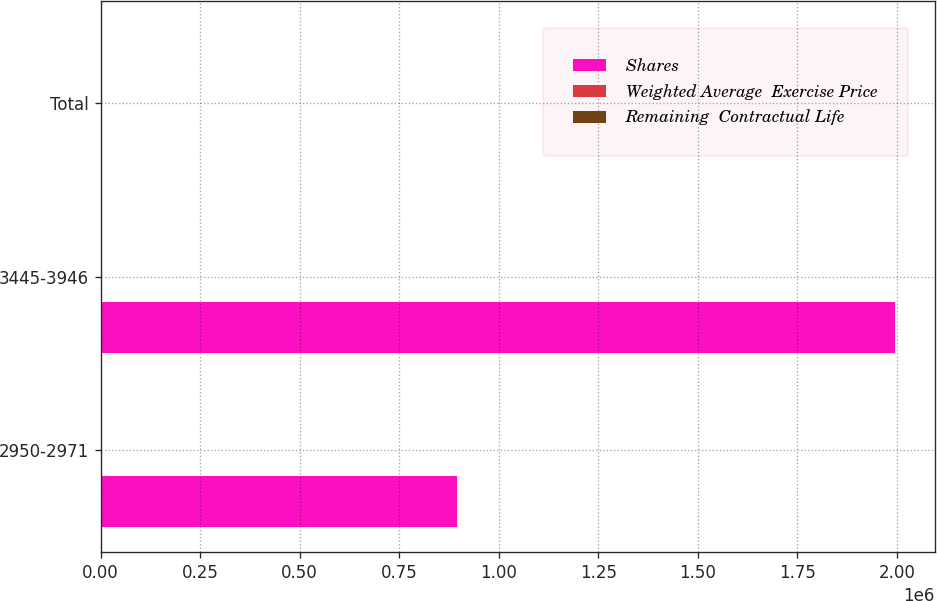Convert chart. <chart><loc_0><loc_0><loc_500><loc_500><stacked_bar_chart><ecel><fcel>2950-2971<fcel>3445-3946<fcel>Total<nl><fcel>Shares<fcel>894054<fcel>1.99501e+06<fcel>32.42<nl><fcel>Weighted Average  Exercise Price<fcel>29.66<fcel>37.66<fcel>35.18<nl><fcel>Remaining  Contractual Life<fcel>1.77<fcel>2.67<fcel>2.39<nl></chart> 